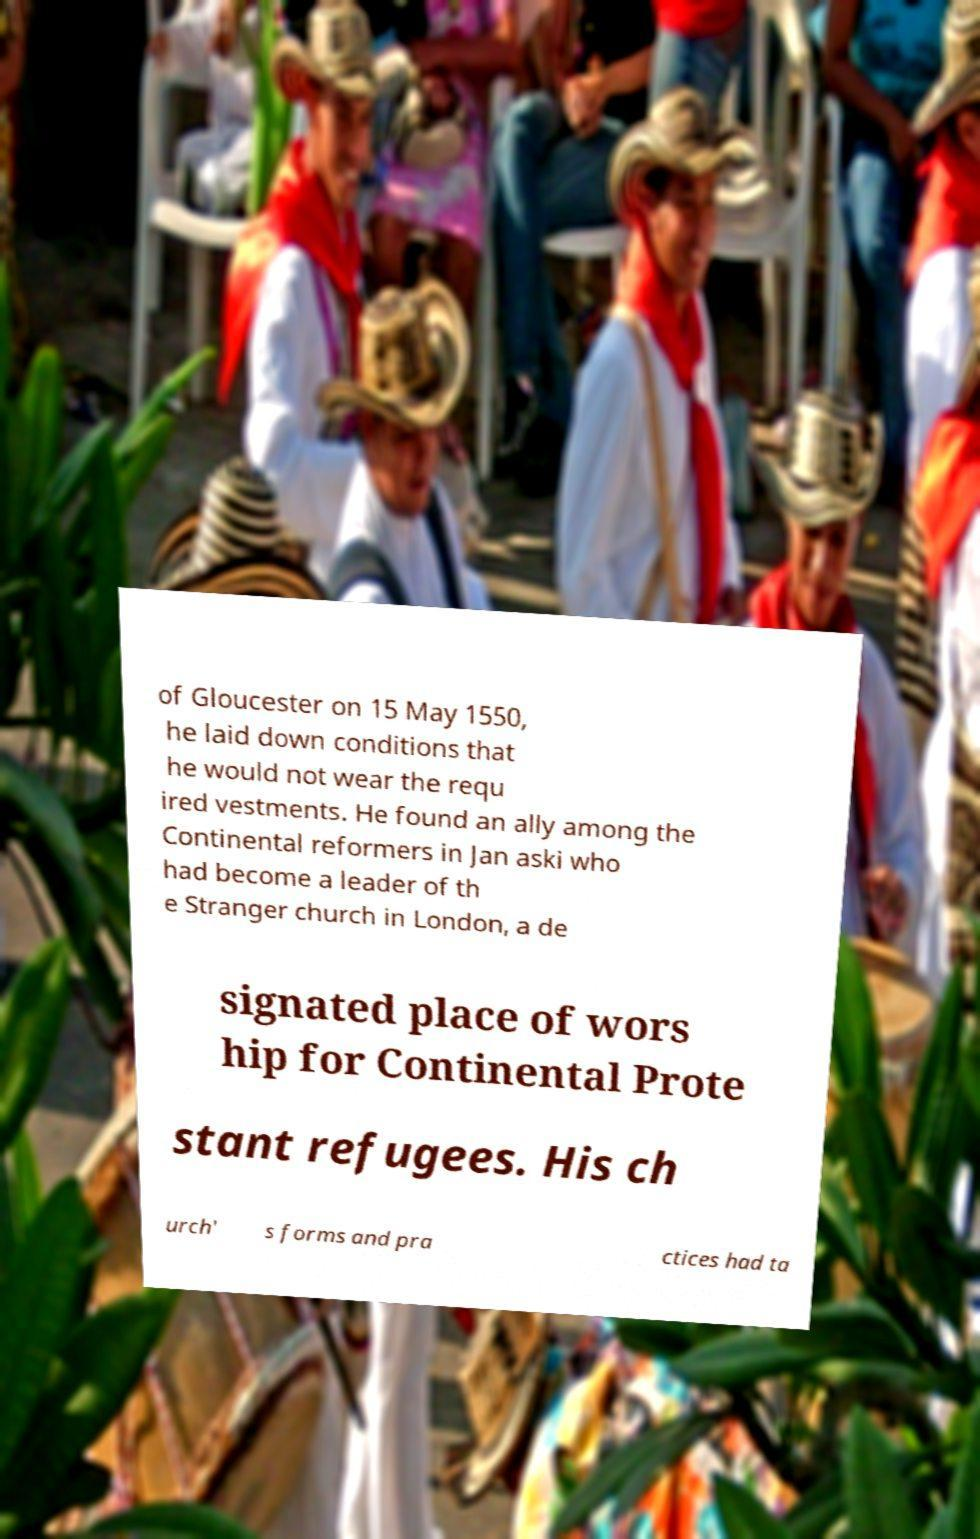For documentation purposes, I need the text within this image transcribed. Could you provide that? of Gloucester on 15 May 1550, he laid down conditions that he would not wear the requ ired vestments. He found an ally among the Continental reformers in Jan aski who had become a leader of th e Stranger church in London, a de signated place of wors hip for Continental Prote stant refugees. His ch urch' s forms and pra ctices had ta 